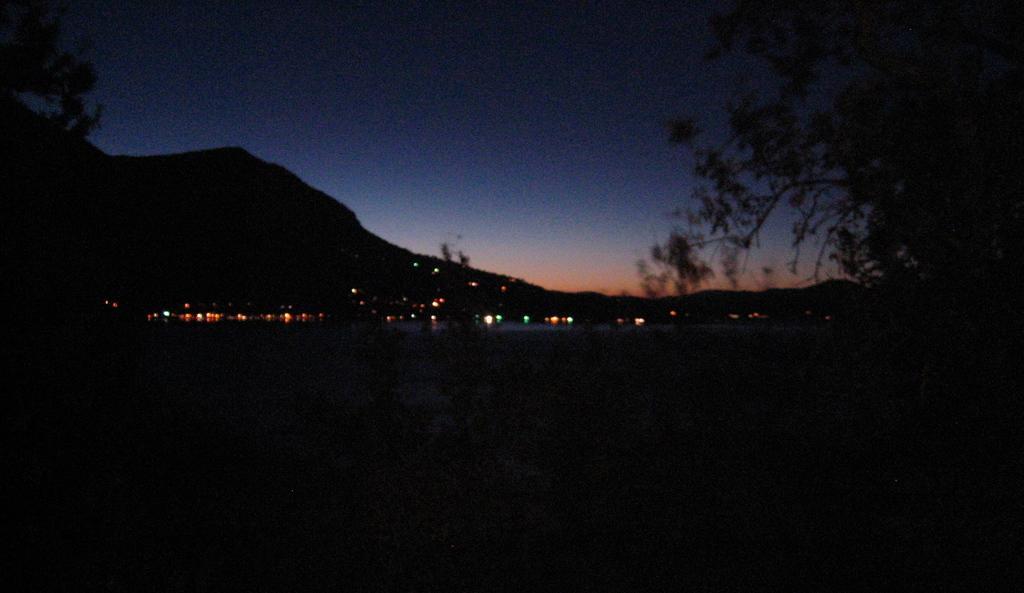Describe this image in one or two sentences. In this image in the background there are lights. On the right side there is a tree. On the left side there are leaves. 